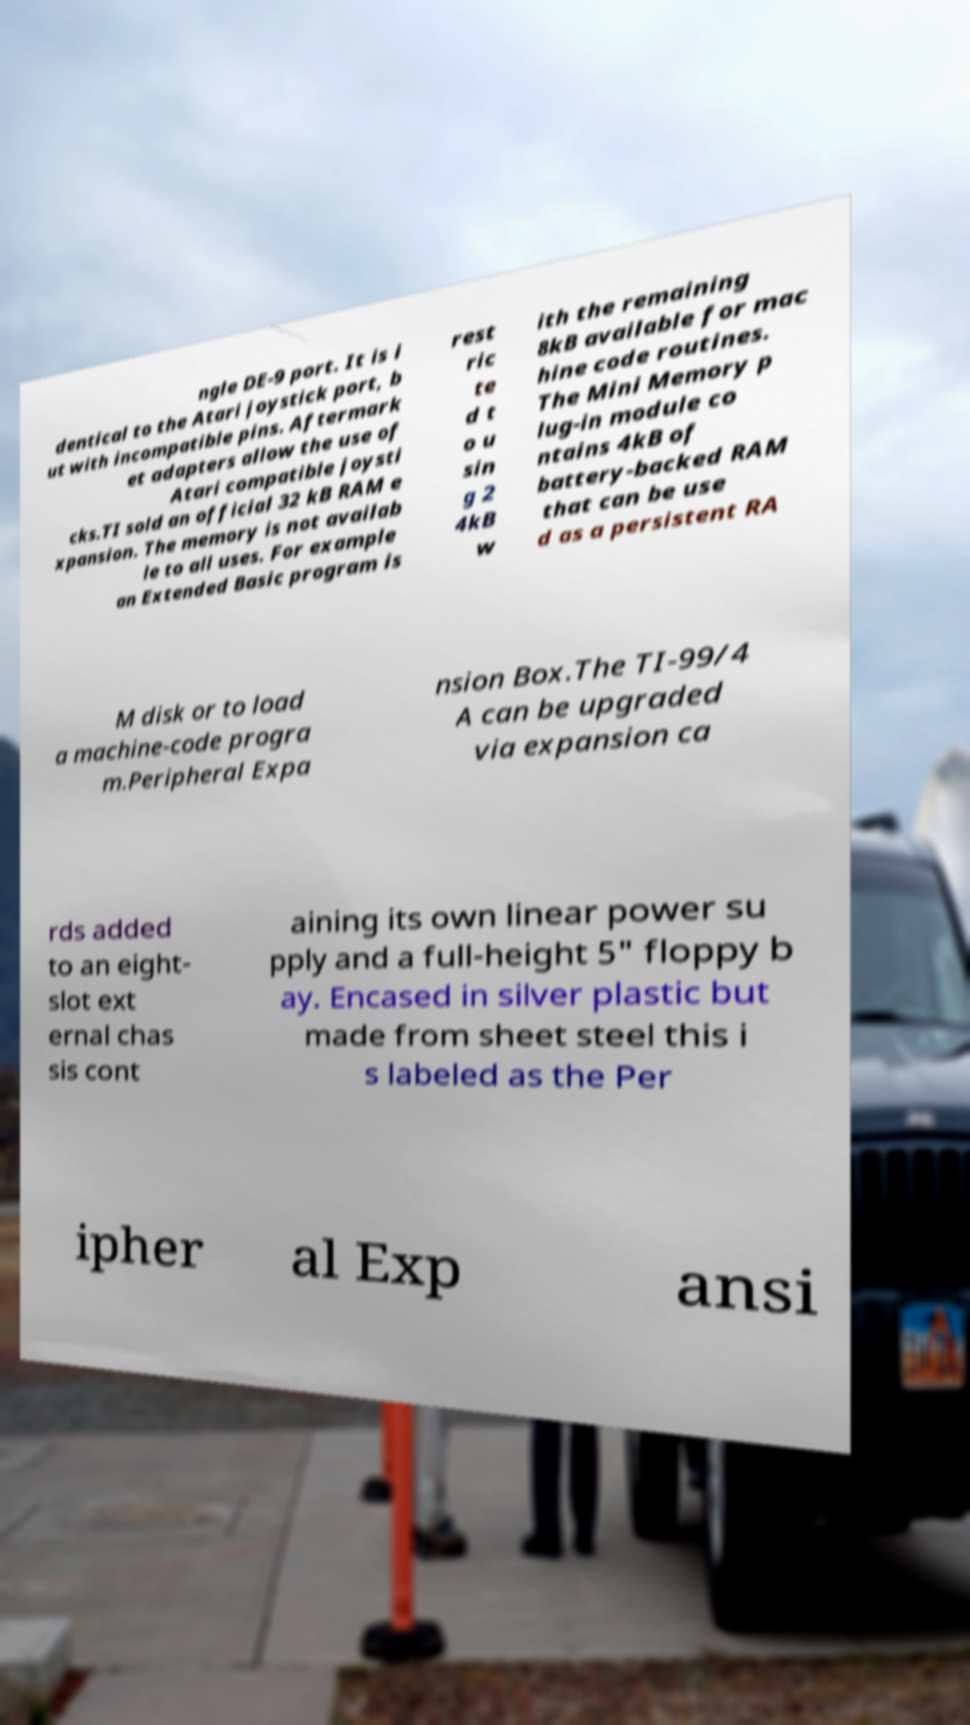There's text embedded in this image that I need extracted. Can you transcribe it verbatim? ngle DE-9 port. It is i dentical to the Atari joystick port, b ut with incompatible pins. Aftermark et adapters allow the use of Atari compatible joysti cks.TI sold an official 32 kB RAM e xpansion. The memory is not availab le to all uses. For example an Extended Basic program is rest ric te d t o u sin g 2 4kB w ith the remaining 8kB available for mac hine code routines. The Mini Memory p lug-in module co ntains 4kB of battery-backed RAM that can be use d as a persistent RA M disk or to load a machine-code progra m.Peripheral Expa nsion Box.The TI-99/4 A can be upgraded via expansion ca rds added to an eight- slot ext ernal chas sis cont aining its own linear power su pply and a full-height 5" floppy b ay. Encased in silver plastic but made from sheet steel this i s labeled as the Per ipher al Exp ansi 